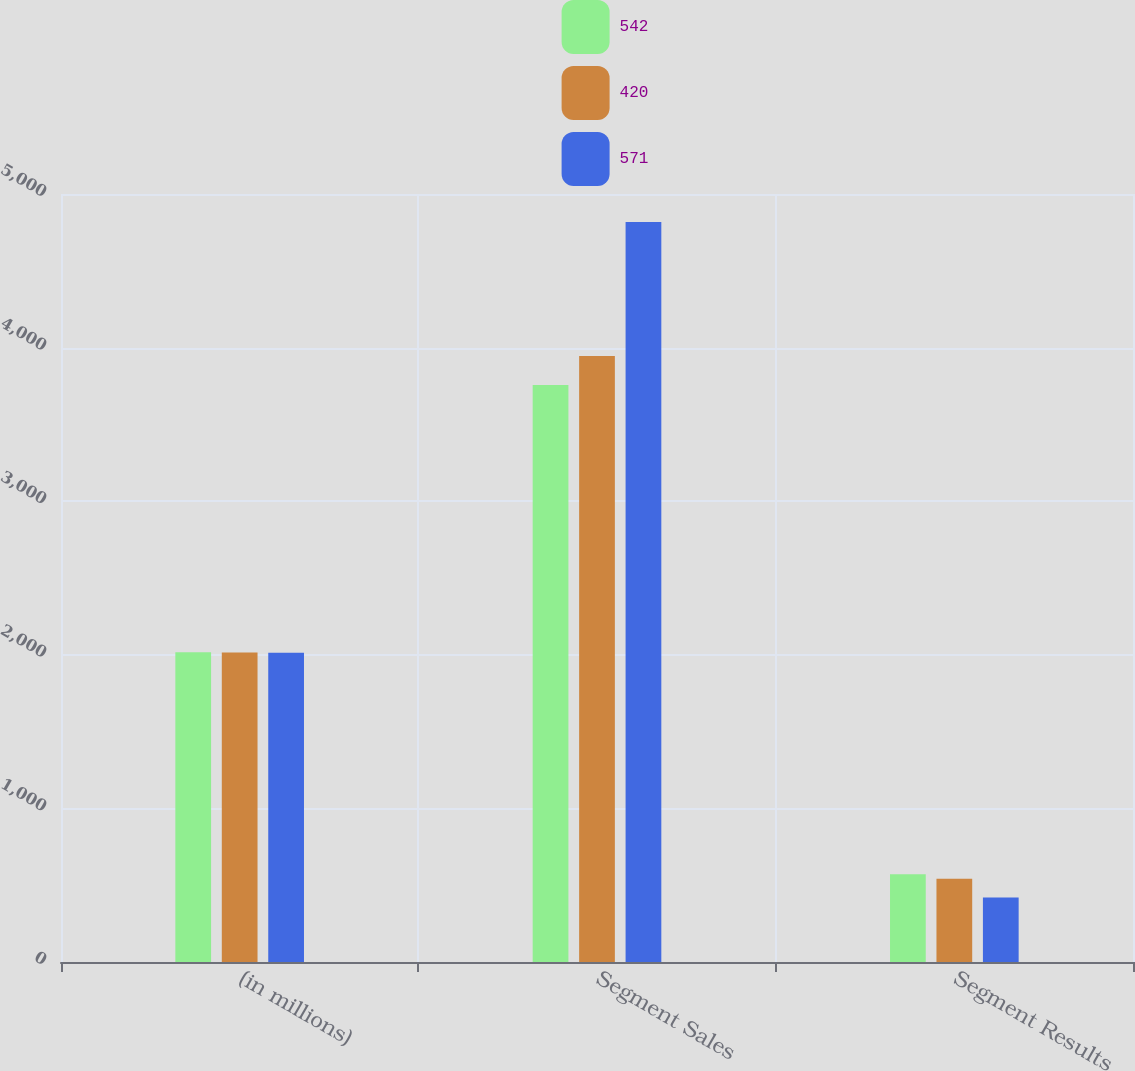Convert chart. <chart><loc_0><loc_0><loc_500><loc_500><stacked_bar_chart><ecel><fcel>(in millions)<fcel>Segment Sales<fcel>Segment Results<nl><fcel>542<fcel>2016<fcel>3756<fcel>571<nl><fcel>420<fcel>2015<fcel>3945<fcel>542<nl><fcel>571<fcel>2014<fcel>4817<fcel>420<nl></chart> 